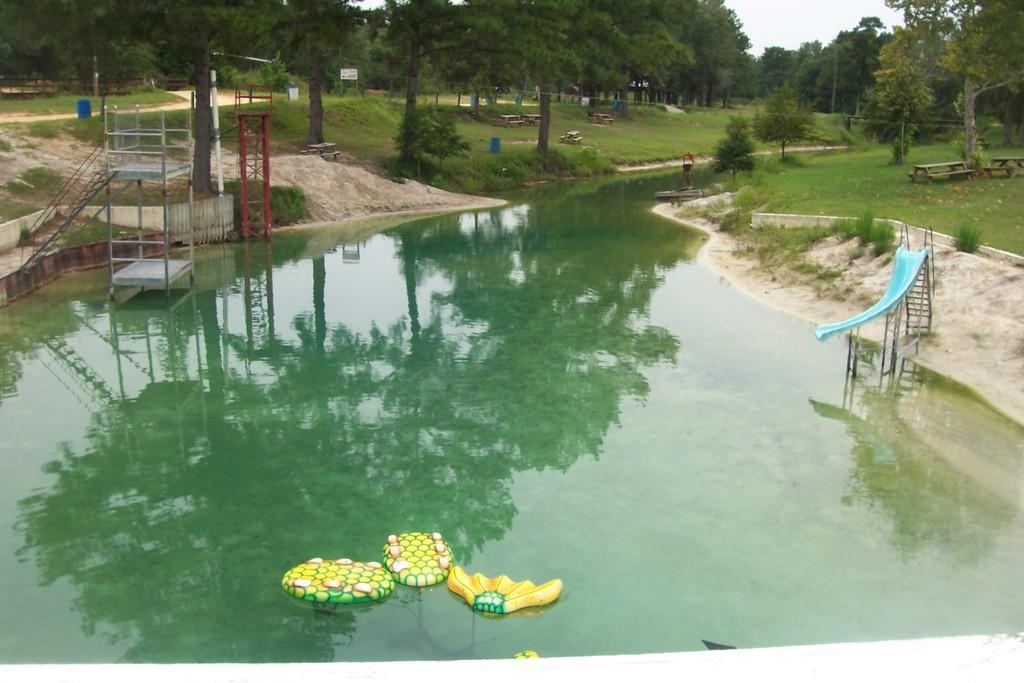What type of vegetation can be seen in the image? There are trees in the image. What can be seen in the water in the image? There are colorful objects on the water. What structures are present in the image? There are poles, a ladder, benches, tables, and a blue slide in the image. What type of barrier is visible in the image? There is fencing in the image. How would you describe the color of the sky in the image? The sky appears to be white in color. Where is the leather shelf located in the image? There is no leather shelf present in the image. What type of feeling is depicted in the image? The image does not depict any specific feeling; it is a scene with various objects and structures. 